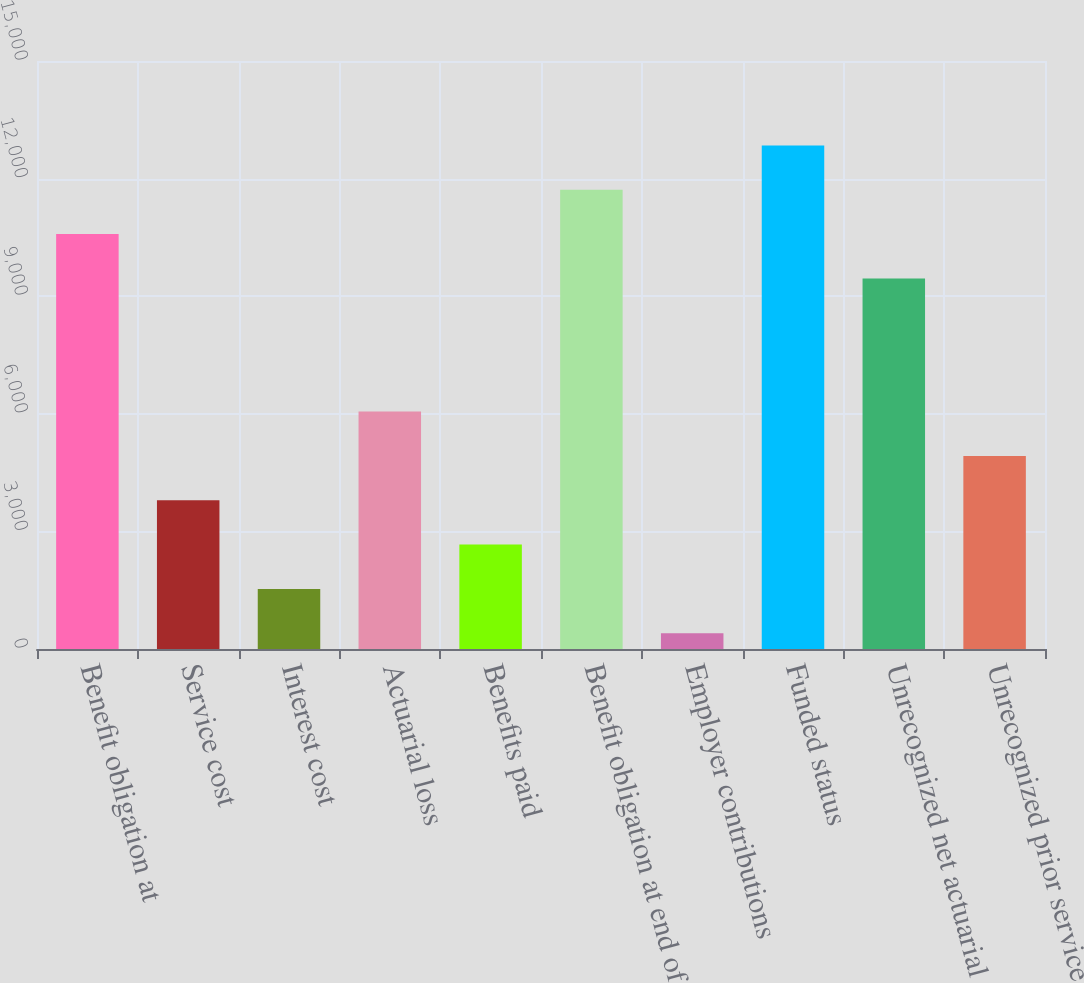<chart> <loc_0><loc_0><loc_500><loc_500><bar_chart><fcel>Benefit obligation at<fcel>Service cost<fcel>Interest cost<fcel>Actuarial loss<fcel>Benefits paid<fcel>Benefit obligation at end of<fcel>Employer contributions<fcel>Funded status<fcel>Unrecognized net actuarial<fcel>Unrecognized prior service<nl><fcel>10583.6<fcel>3795.2<fcel>1532.4<fcel>6058<fcel>2663.8<fcel>11715<fcel>401<fcel>12846.4<fcel>9452.2<fcel>4926.6<nl></chart> 